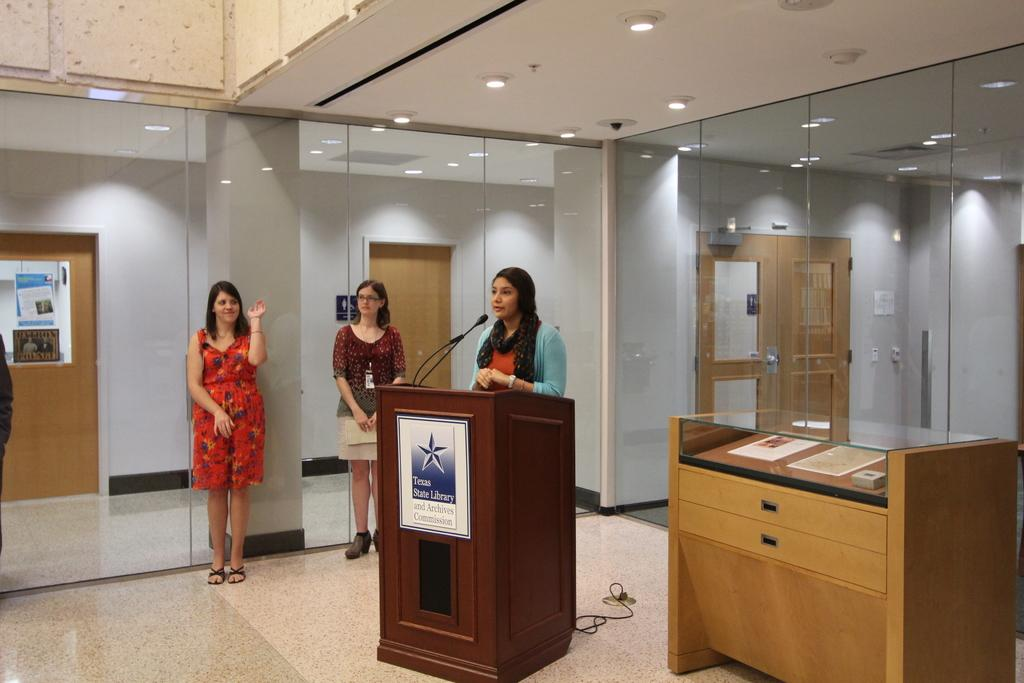How many women are in the image? There are three women in the image. What is one of the women doing in the image? One of the women is standing in front of a podium. What objects can be seen in the image besides the women? There are glasses visible in the image. What can be seen in the background of the image? There are brown color doors and a wall in the background of the image. What type of breakfast is being served in the image? There is no breakfast present in the image. Is there a rainstorm occurring in the image? There is no indication of a rainstorm in the image. 